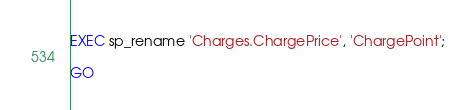Convert code to text. <code><loc_0><loc_0><loc_500><loc_500><_SQL_>EXEC sp_rename 'Charges.ChargePrice', 'ChargePoint';

GO
</code> 